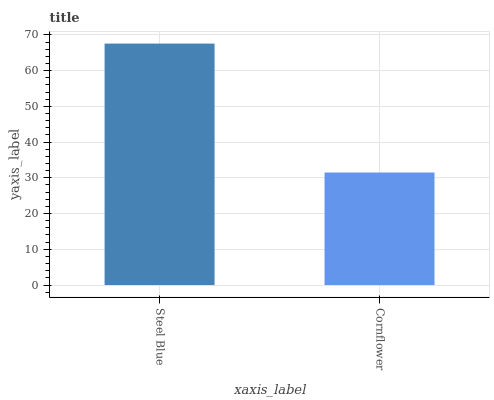Is Cornflower the minimum?
Answer yes or no. Yes. Is Steel Blue the maximum?
Answer yes or no. Yes. Is Cornflower the maximum?
Answer yes or no. No. Is Steel Blue greater than Cornflower?
Answer yes or no. Yes. Is Cornflower less than Steel Blue?
Answer yes or no. Yes. Is Cornflower greater than Steel Blue?
Answer yes or no. No. Is Steel Blue less than Cornflower?
Answer yes or no. No. Is Steel Blue the high median?
Answer yes or no. Yes. Is Cornflower the low median?
Answer yes or no. Yes. Is Cornflower the high median?
Answer yes or no. No. Is Steel Blue the low median?
Answer yes or no. No. 